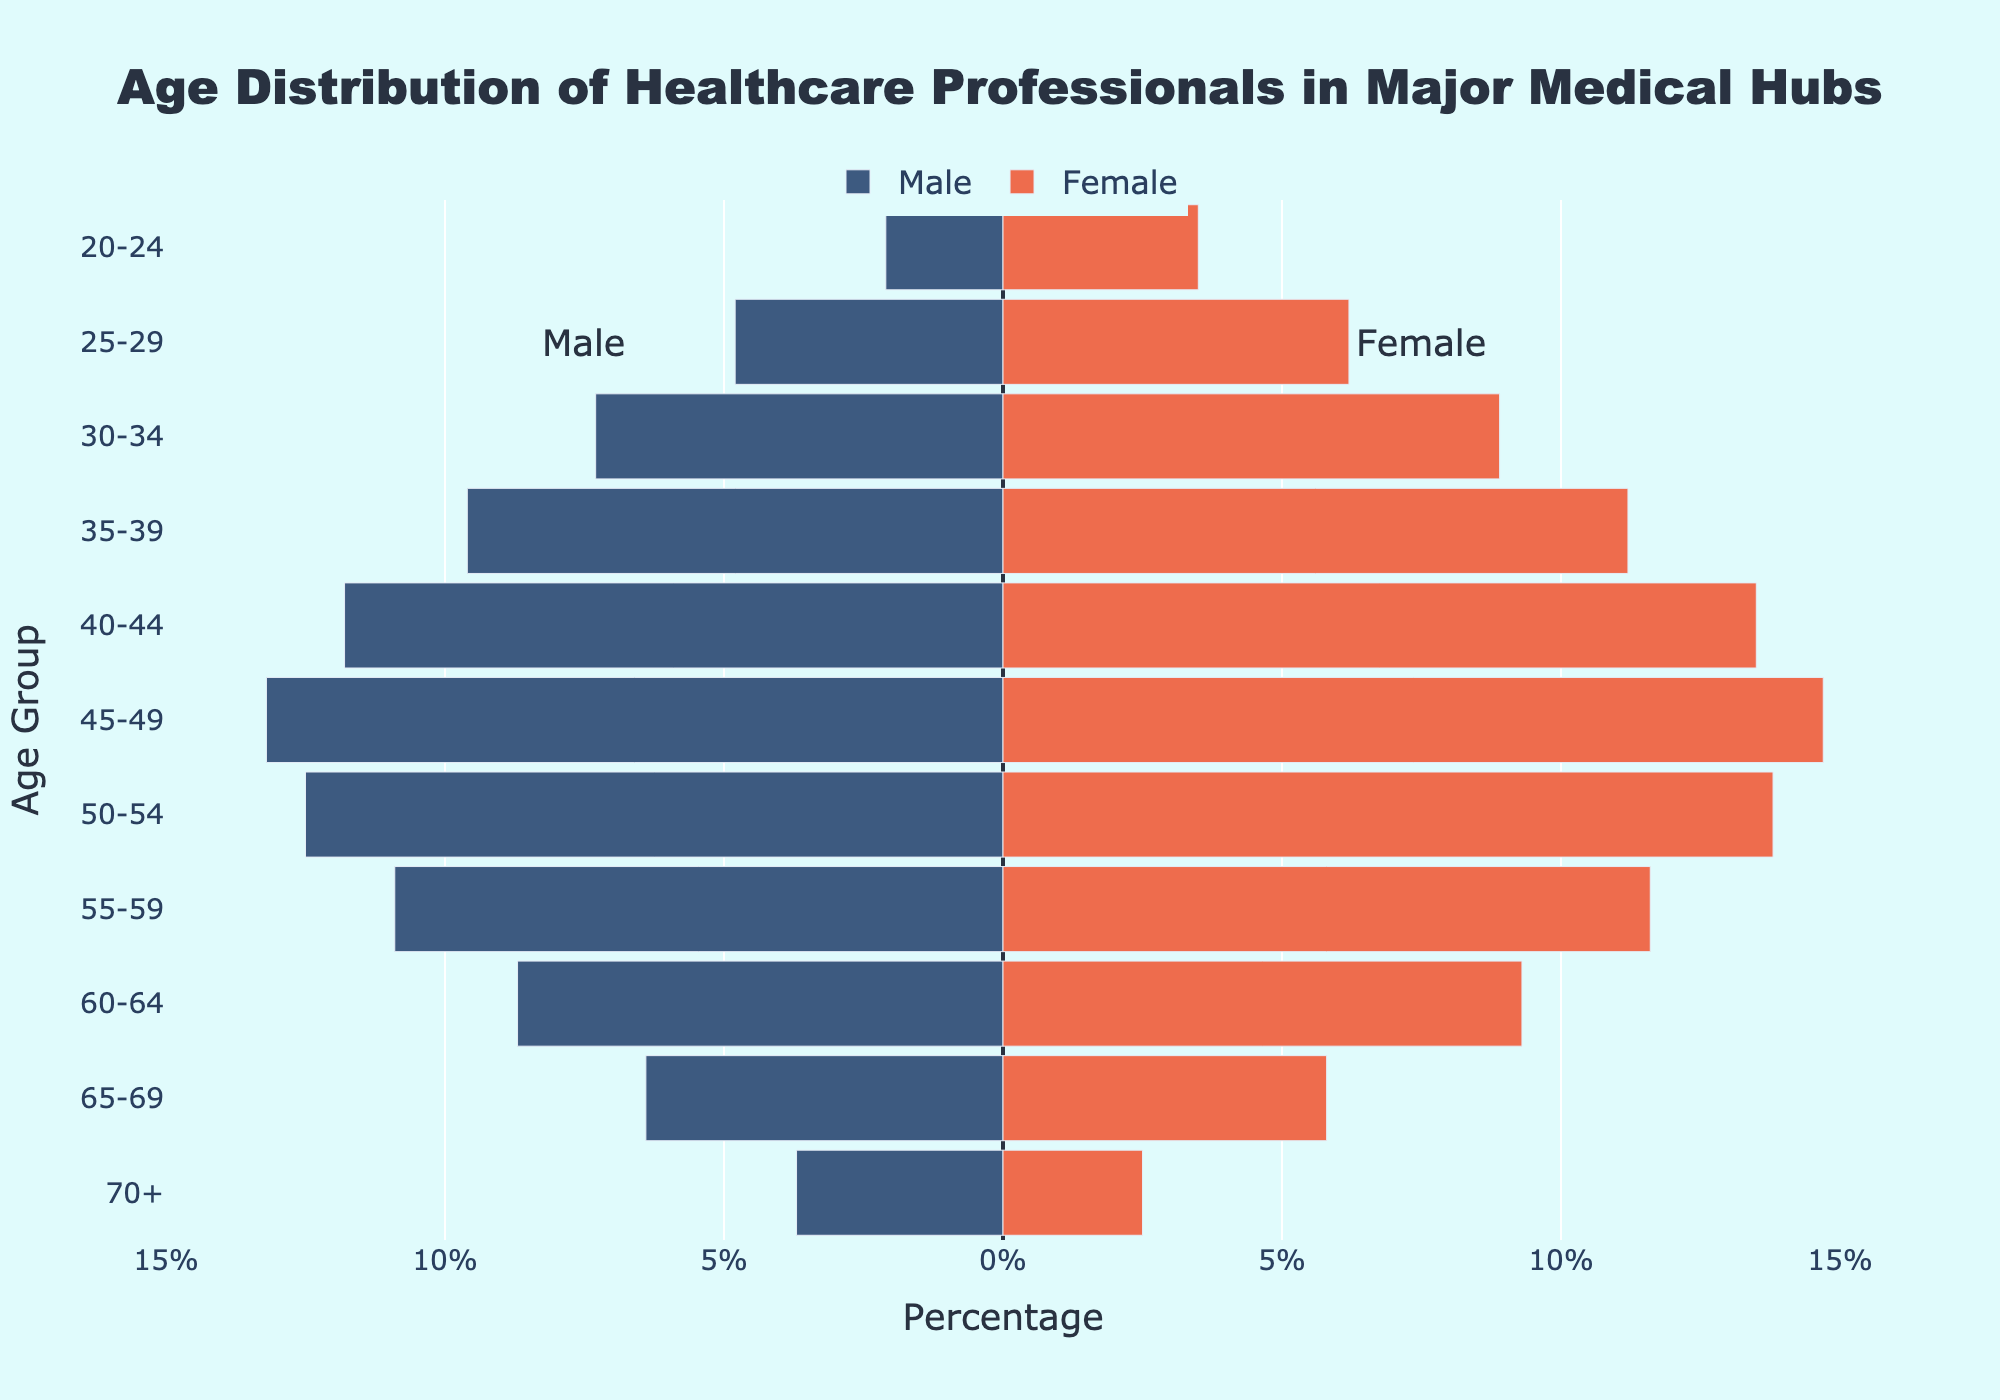What is the title of the figure? The title is located at the top center of the figure and usually highlights the main topic being visualized. Here, it reads "Age Distribution of Healthcare Professionals in Major Medical Hubs" in large, bold font.
Answer: Age Distribution of Healthcare Professionals in Major Medical Hubs What colors represent males and females in the figure? In the figure, bars representing males and females use different colors. The color of the male bars is dark blue (appears on the left side) and the female bars are coral (appears on the right side).
Answer: Dark blue for males and coral for females Which age group has the highest percentage of healthcare professionals for both males and females? Looking at the lengths of the bars for each age group, the maximum for both males and females is in the 45-49 age group.
Answer: 45-49 In which age group do females outnumber males by the largest margin? The Female percentage subtracted by the Male percentage for each age group, the 20-24 age group has the largest positive difference between females and males: 3.5% (females) - 2.1% (males) = 1.4%.
Answer: 20-24 Compare the percentage of males aged 65-69 to those aged 70+. Which group has a higher percentage? The figure shows the values directly. Males aged 65-69 have a percentage of 6.4%, while those aged 70+ have 3.7%.
Answer: 65-69 Which age group shows a reversed trend where the male percentage surpasses the female percentage? Examine the bars for overriding instances throughout and find that in age groups 65-69 and 70+, the males' percentage is greater than the females'.
Answer: 65-69 and 70+ What is the total percentage of healthcare professionals in the 55-59 age group for both genders combined? Summing up the absolute values for males and females: 10.9% (males) + 11.6% (females) = 22.5%
Answer: 22.5% What age group has the smallest total percentage of healthcare professionals for both male and female combined? Looking for the shortest male and female bars combined, the group 20-24 has the smallest total percentage: 2.1% (males) + 3.5% (females) = 5.6%.
Answer: 20-24 